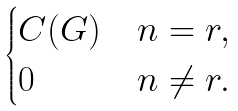Convert formula to latex. <formula><loc_0><loc_0><loc_500><loc_500>\begin{cases} C ( G ) & n = r , \\ 0 & n \ne r . \end{cases}</formula> 